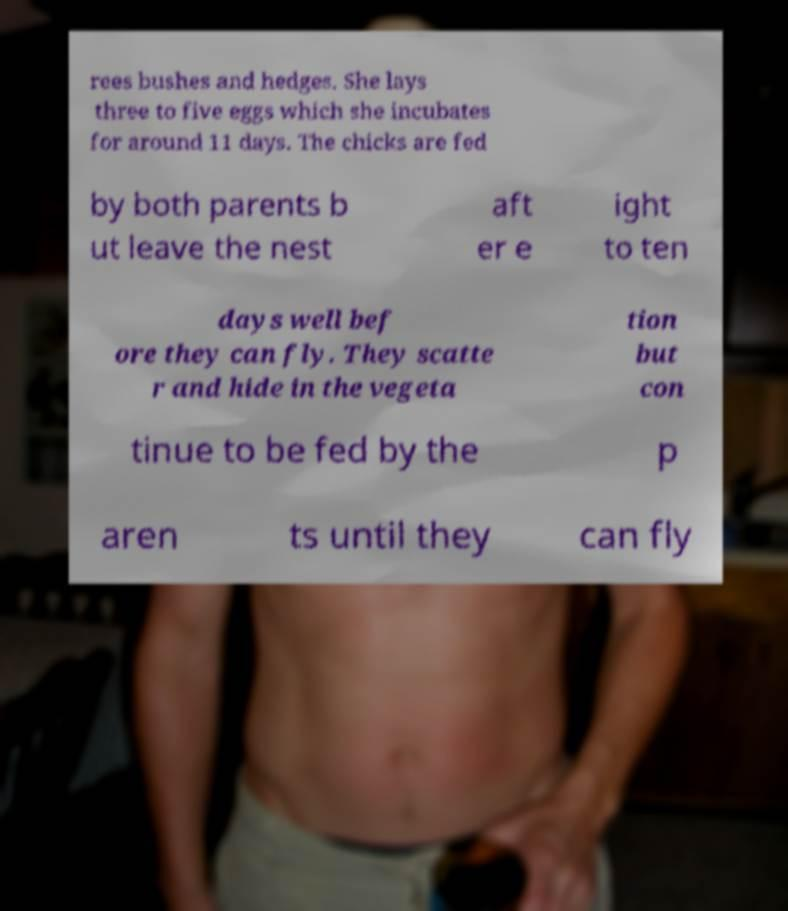Could you extract and type out the text from this image? rees bushes and hedges. She lays three to five eggs which she incubates for around 11 days. The chicks are fed by both parents b ut leave the nest aft er e ight to ten days well bef ore they can fly. They scatte r and hide in the vegeta tion but con tinue to be fed by the p aren ts until they can fly 